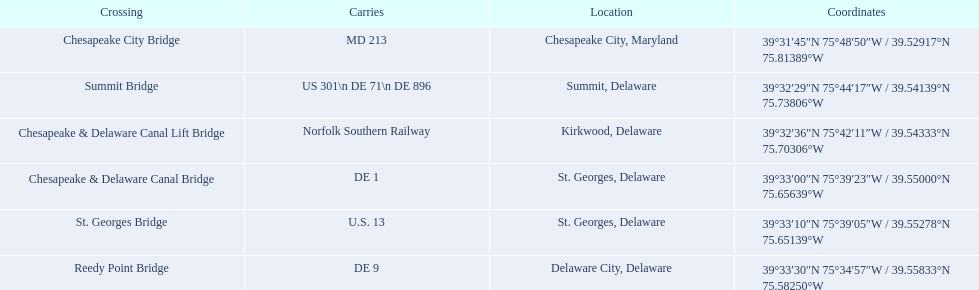What is being conveyed in the canal? MD 213, US 301\n DE 71\n DE 896, Norfolk Southern Railway, DE 1, U.S. 13, DE 9. Among them, which has the maximum number of diverse routes? US 301\n DE 71\n DE 896. To which junction does that refer? Summit Bridge. I'm looking to parse the entire table for insights. Could you assist me with that? {'header': ['Crossing', 'Carries', 'Location', 'Coordinates'], 'rows': [['Chesapeake City Bridge', 'MD 213', 'Chesapeake City, Maryland', '39°31′45″N 75°48′50″W\ufeff / \ufeff39.52917°N 75.81389°W'], ['Summit Bridge', 'US 301\\n DE 71\\n DE 896', 'Summit, Delaware', '39°32′29″N 75°44′17″W\ufeff / \ufeff39.54139°N 75.73806°W'], ['Chesapeake & Delaware Canal Lift Bridge', 'Norfolk Southern Railway', 'Kirkwood, Delaware', '39°32′36″N 75°42′11″W\ufeff / \ufeff39.54333°N 75.70306°W'], ['Chesapeake & Delaware Canal Bridge', 'DE 1', 'St.\xa0Georges, Delaware', '39°33′00″N 75°39′23″W\ufeff / \ufeff39.55000°N 75.65639°W'], ['St.\xa0Georges Bridge', 'U.S.\xa013', 'St.\xa0Georges, Delaware', '39°33′10″N 75°39′05″W\ufeff / \ufeff39.55278°N 75.65139°W'], ['Reedy Point Bridge', 'DE\xa09', 'Delaware City, Delaware', '39°33′30″N 75°34′57″W\ufeff / \ufeff39.55833°N 75.58250°W']]} What is being transferred in the canal? MD 213, US 301\n DE 71\n DE 896, Norfolk Southern Railway, DE 1, U.S. 13, DE 9. Of those, which has the greatest number of unique courses? US 301\n DE 71\n DE 896. To which crossroads does that correspond? Summit Bridge. 